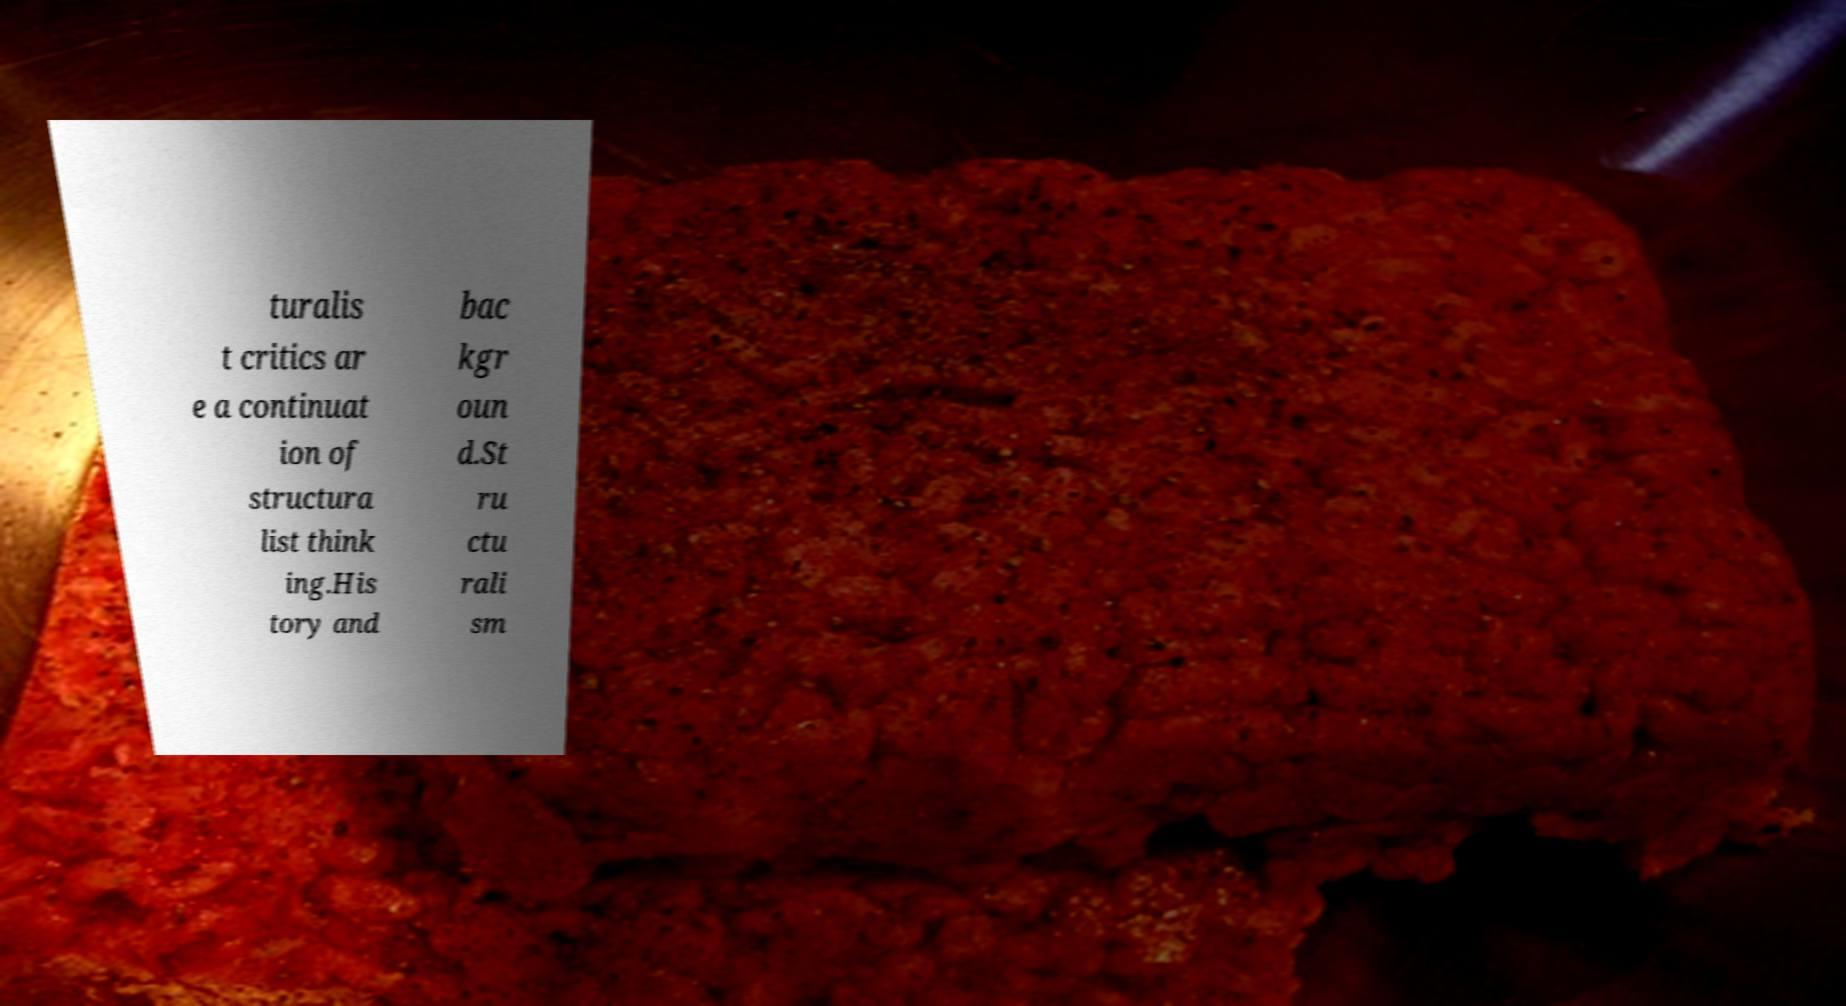For documentation purposes, I need the text within this image transcribed. Could you provide that? turalis t critics ar e a continuat ion of structura list think ing.His tory and bac kgr oun d.St ru ctu rali sm 